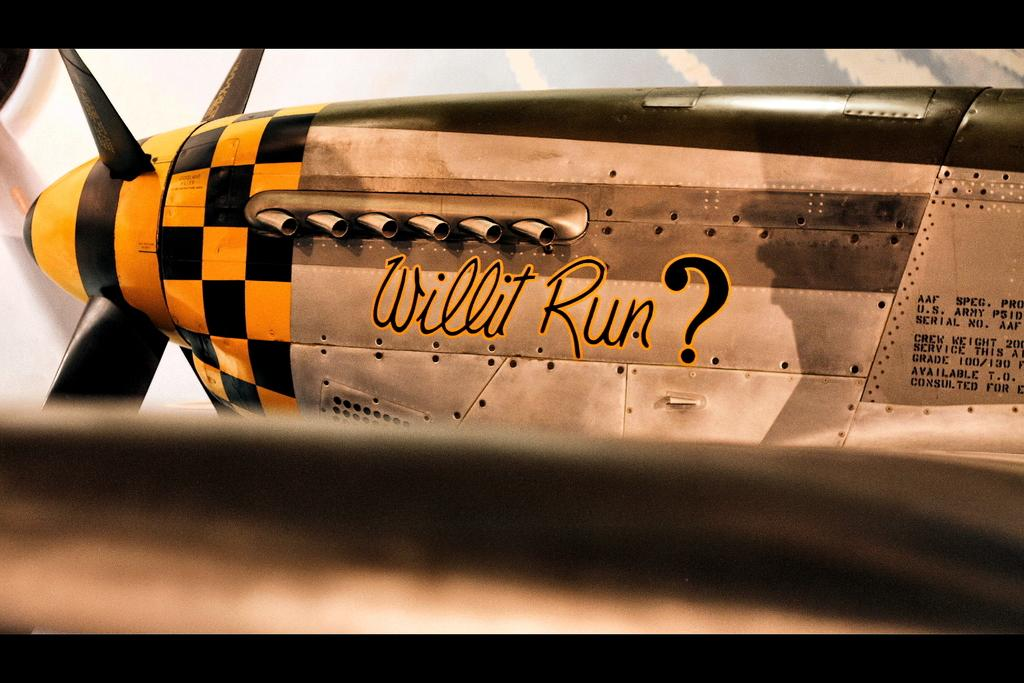What is the main subject of the image? The main subject of the image is an aircraft. Are there any words or letters on the aircraft? Yes, there is text on the aircraft. What color is the background of the image? The background of the image is white. How much money is being exchanged between the apple and the aircraft in the image? There is no money or apple present in the image, so this exchange cannot be observed. 